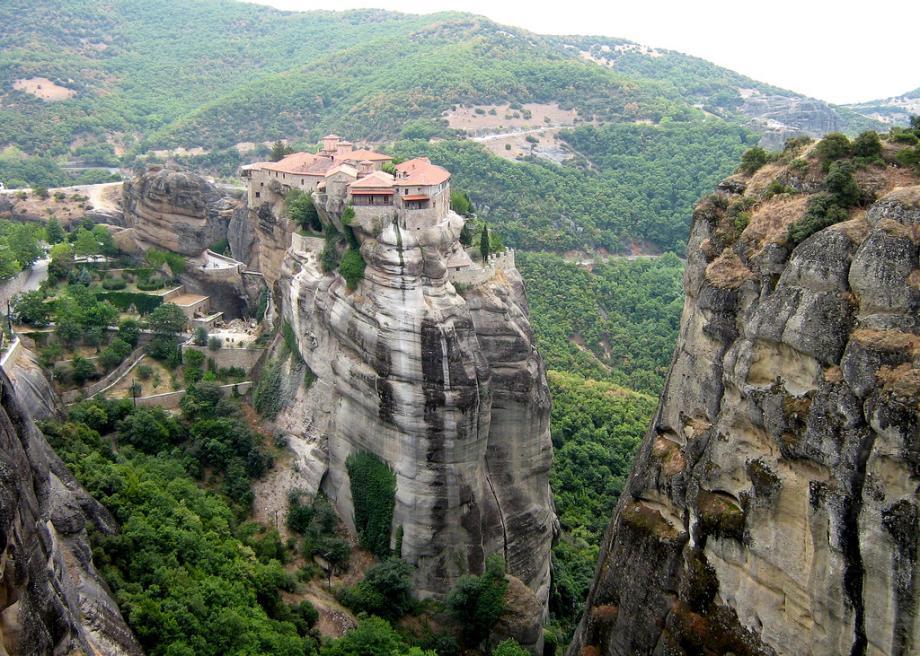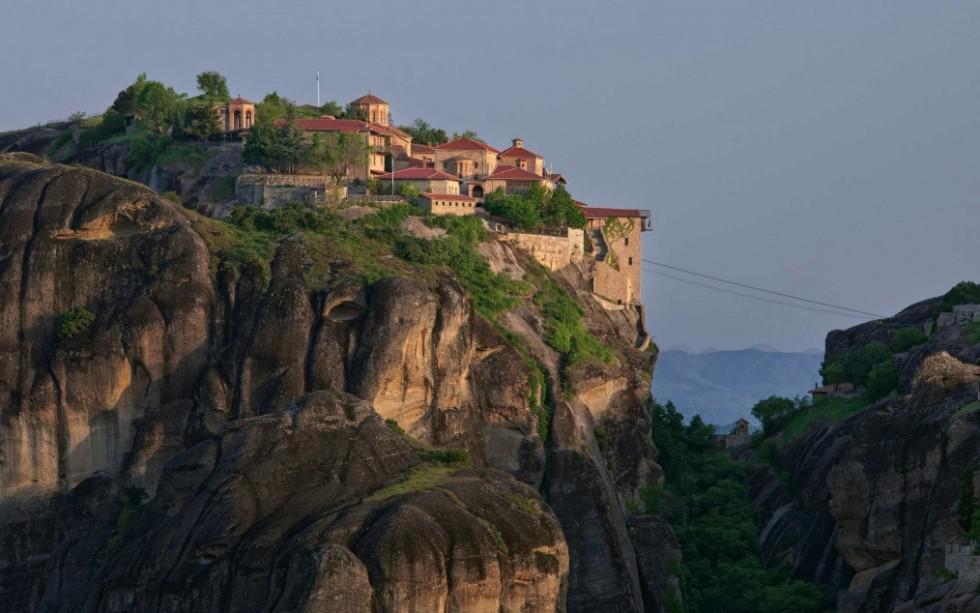The first image is the image on the left, the second image is the image on the right. For the images shown, is this caption "One image has misty clouds in between mountains." true? Answer yes or no. No. 